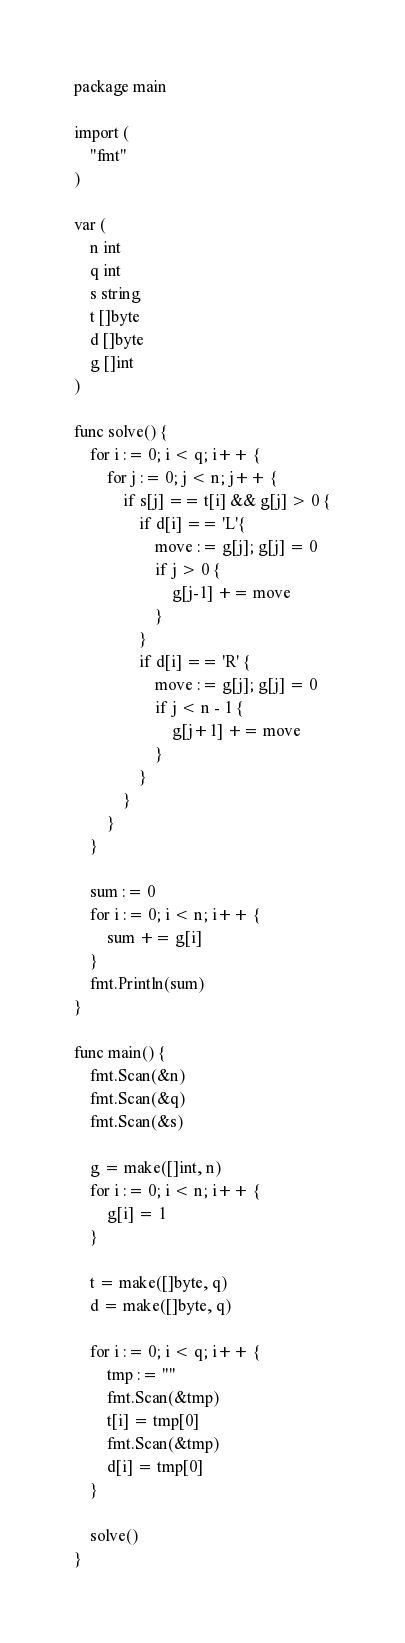Convert code to text. <code><loc_0><loc_0><loc_500><loc_500><_Go_>package main

import (
	"fmt"
)

var (
	n int
	q int
	s string
	t []byte
	d []byte
	g []int
)

func solve() {
	for i := 0; i < q; i++ {
		for j := 0; j < n; j++ {
			if s[j] == t[i] && g[j] > 0 {
				if d[i] == 'L'{
					move := g[j]; g[j] = 0
					if j > 0 {
						g[j-1] += move
					}
				}
				if d[i] == 'R' {
					move := g[j]; g[j] = 0
					if j < n - 1 {
						g[j+1] += move
					}
				}
			}
		}
	}

	sum := 0
	for i := 0; i < n; i++ {
		sum += g[i]
	}
	fmt.Println(sum)
}

func main() {
	fmt.Scan(&n)
	fmt.Scan(&q)
	fmt.Scan(&s)

	g = make([]int, n)
	for i := 0; i < n; i++ {
		g[i] = 1
	}

	t = make([]byte, q)
	d = make([]byte, q)

	for i := 0; i < q; i++ {
		tmp := ""
		fmt.Scan(&tmp)
		t[i] = tmp[0]
		fmt.Scan(&tmp)
		d[i] = tmp[0]
	}

	solve()
}
</code> 